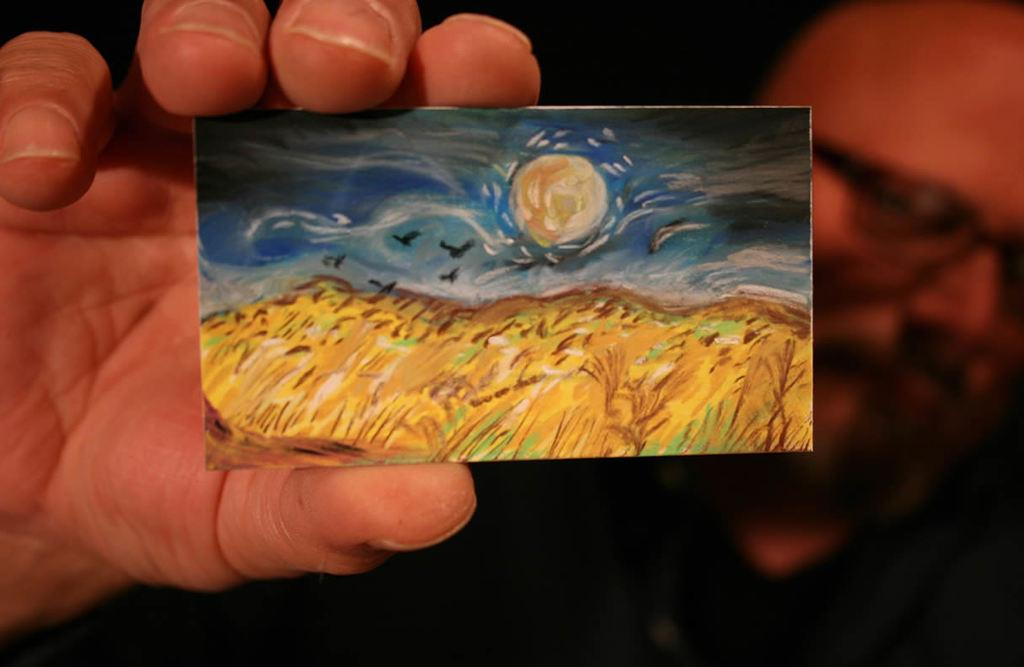What can be observed about the background of the image? The background portion of the picture is blurred. Who is present in the image? There is a man in the image. What is the man wearing? The man is wearing spectacles. What is the man holding in the image? The man is holding a card. What is depicted on the card? There is a painting on the card. What type of whistle can be heard in the image? There is no whistle present in the image, so no sound can be heard. Is there any destruction visible in the image? There is no destruction present in the image. What type of plantation is shown in the image? There is no plantation present in the image. 